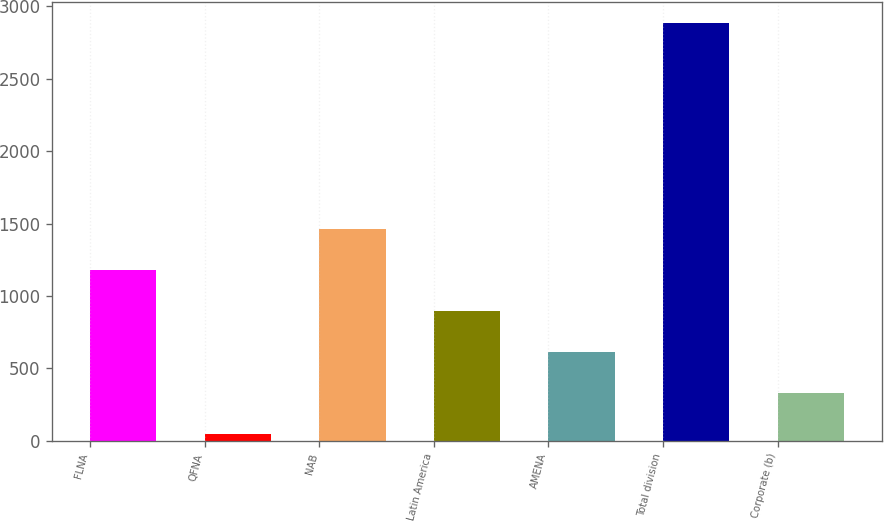Convert chart. <chart><loc_0><loc_0><loc_500><loc_500><bar_chart><fcel>FLNA<fcel>QFNA<fcel>NAB<fcel>Latin America<fcel>AMENA<fcel>Total division<fcel>Corporate (b)<nl><fcel>1179.6<fcel>44<fcel>1463.5<fcel>895.7<fcel>611.8<fcel>2883<fcel>327.9<nl></chart> 